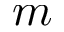<formula> <loc_0><loc_0><loc_500><loc_500>m</formula> 